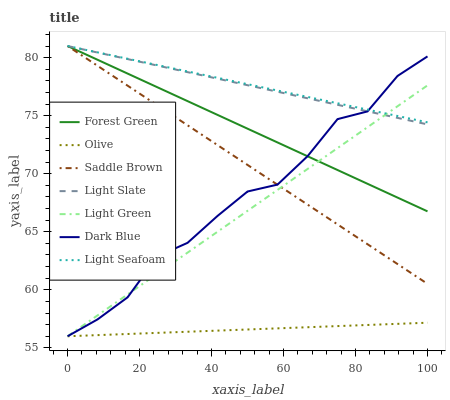Does Olive have the minimum area under the curve?
Answer yes or no. Yes. Does Light Seafoam have the maximum area under the curve?
Answer yes or no. Yes. Does Dark Blue have the minimum area under the curve?
Answer yes or no. No. Does Dark Blue have the maximum area under the curve?
Answer yes or no. No. Is Light Seafoam the smoothest?
Answer yes or no. Yes. Is Dark Blue the roughest?
Answer yes or no. Yes. Is Forest Green the smoothest?
Answer yes or no. No. Is Forest Green the roughest?
Answer yes or no. No. Does Dark Blue have the lowest value?
Answer yes or no. Yes. Does Forest Green have the lowest value?
Answer yes or no. No. Does Saddle Brown have the highest value?
Answer yes or no. Yes. Does Dark Blue have the highest value?
Answer yes or no. No. Is Olive less than Light Slate?
Answer yes or no. Yes. Is Light Seafoam greater than Olive?
Answer yes or no. Yes. Does Saddle Brown intersect Light Green?
Answer yes or no. Yes. Is Saddle Brown less than Light Green?
Answer yes or no. No. Is Saddle Brown greater than Light Green?
Answer yes or no. No. Does Olive intersect Light Slate?
Answer yes or no. No. 